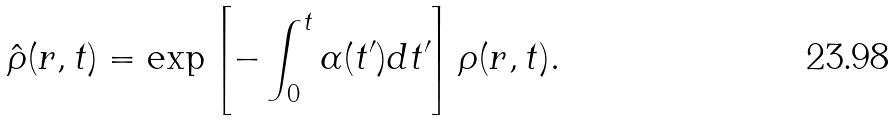Convert formula to latex. <formula><loc_0><loc_0><loc_500><loc_500>\hat { \rho } ( { r } , t ) = \exp \left [ - \int _ { 0 } ^ { t } \alpha ( t ^ { \prime } ) { d } t ^ { \prime } \right ] { \rho } ( { r } , t ) .</formula> 